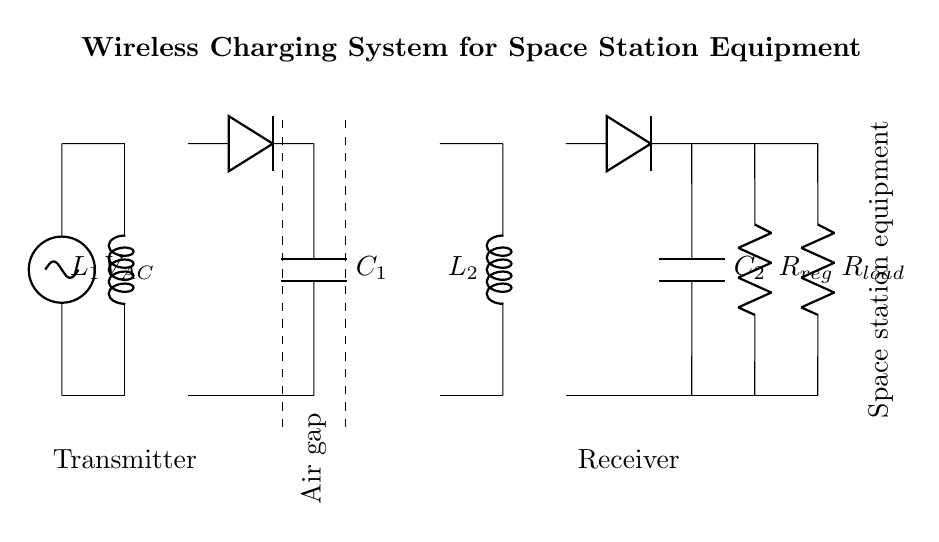What type of power source is used in this circuit? The circuit uses an alternating current (AC) source, which is indicated by the symbol for the AC voltage source.
Answer: AC What components are present in the primary side? The primary side consists of an inductor labeled L1 and an AC source; these components are connected in series.
Answer: L1 and AC source What is the function of capacitor C1? Capacitor C1 is used for filtering the rectified output to smooth the voltage, ensuring a stable DC supply is delivered to the load.
Answer: Filtering How many coils are in the circuit? There are two coils in the circuit: the primary coil labeled L1 and the secondary coil labeled L2.
Answer: Two What is the purpose of the air gap in the circuit? The air gap allows for the transfer of energy via magnetic fields between the primary and secondary coils without direct contact, enabling wireless charging.
Answer: Energy transfer What is the role of the rectifier on the secondary side? The rectifier on the secondary side converts the alternating current generated in the secondary coil into direct current suitable for powering the load.
Answer: Conversion What does the resistor labeled R_load represent? R_load represents the load that consumes power from the charging system, typically representing the equipment being powered in the space station.
Answer: Load 